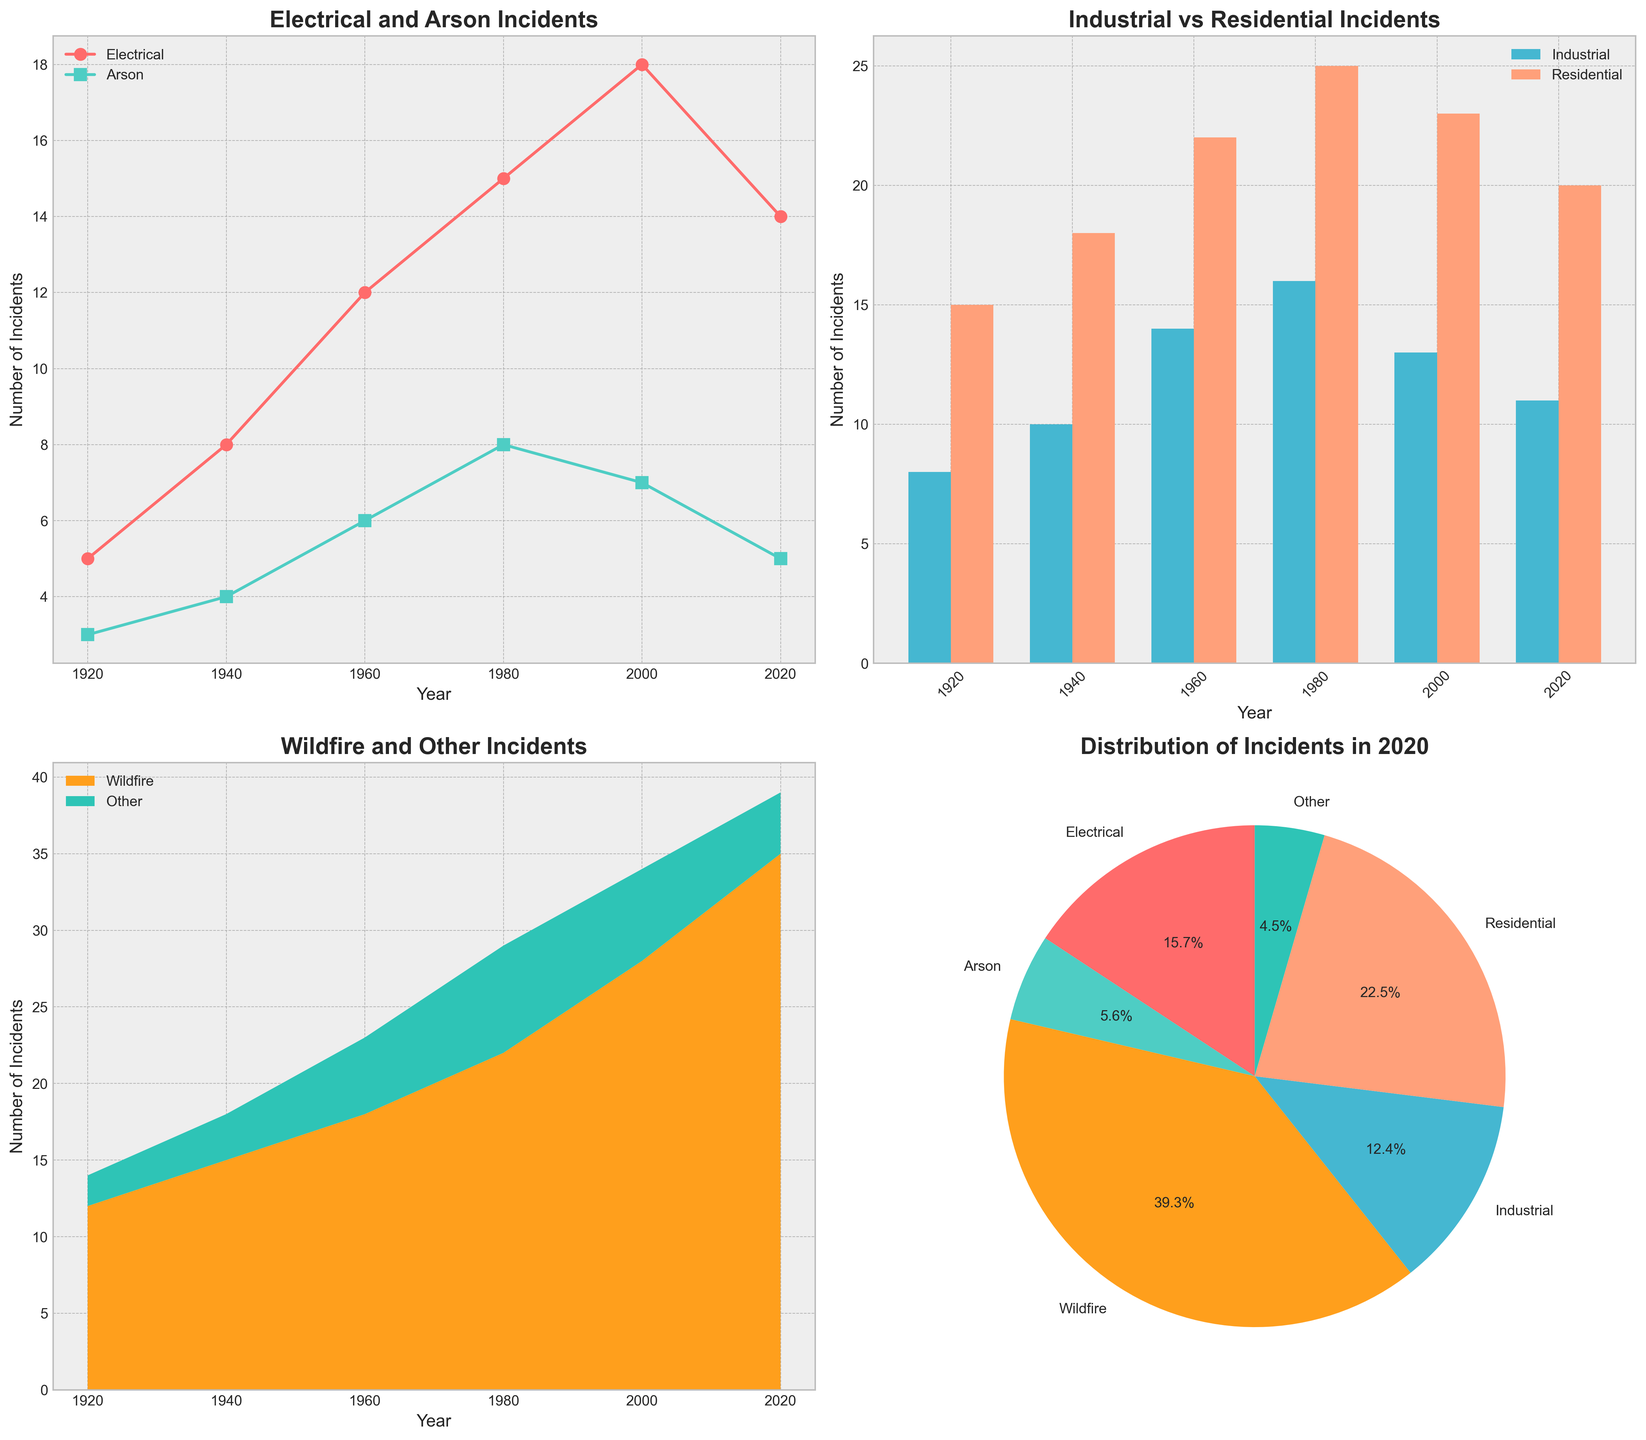What are the titles of the subplots? The titles of the subplots can be found at the top of each individual plot, written in bold font. The first subplot is titled 'Electrical and Arson Incidents', the second is 'Industrial vs Residential Incidents', the third is 'Wildfire and Other Incidents', and the fourth is 'Distribution of Incidents in 2020'.
Answer: Electrical and Arson Incidents; Industrial vs Residential Incidents; Wildfire and Other Incidents; Distribution of Incidents in 2020 Which year had the highest number of Industrial incidents? To answer this, look at the bar plot in the top-right subplot titled 'Industrial vs Residential Incidents'. The bars representing Industrial incidents are identified by their blue color. The highest bar can be visually identified, which corresponds to the year 1980.
Answer: 1980 In 2020, how does the number of Wildfire incidents compare to Residential incidents? Check the stacked area plot and pie chart to compare Wildfire incidents (orange in the area plot) and Residential incidents (peach color in the pie chart). From the area plot, 2020 shows about 35 Wildfire incidents. The pie chart shows Residential incidents form a smaller slice than Wildfire incidents.
Answer: Wildfire incidents are greater What is the sum of Electrical and Arson incidents in 1940? First, find the values for Electrical (8) and Arson (4) incidents in 1940 using the line plot. Then add them together: 8 + 4 = 12.
Answer: 12 What is the difference in the number of Residential incidents between 1980 and 2020? From the data on the bar plot, the number of Residential incidents in 1980 is 25 and in 2020 it is 20. The difference is calculated as 25 - 20 = 5.
Answer: 5 Which type of incident had the smallest share in 2020? The pie chart in the bottom-right subplot labels each segment representing types of incidents in 2020. The smallest slice corresponds to the 'Other' category.
Answer: Other By approximately how much did the number of Wildfire incidents increase from 2000 to 2020? Compare the numbers from the stacked area plot for Wildfire incidents (orange) in 2000 and 2020. In 2000, it’s about 28; in 2020, it’s 35. The approximate increase is 35 - 28 = 7.
Answer: 7 How many total incident categories are displayed in the pie chart? Count the number of categories from the legend of the pie chart, where each type of incident (slice) is listed. There are six categories: Electrical, Arson, Wildfire, Industrial, Residential, and Other.
Answer: 6 